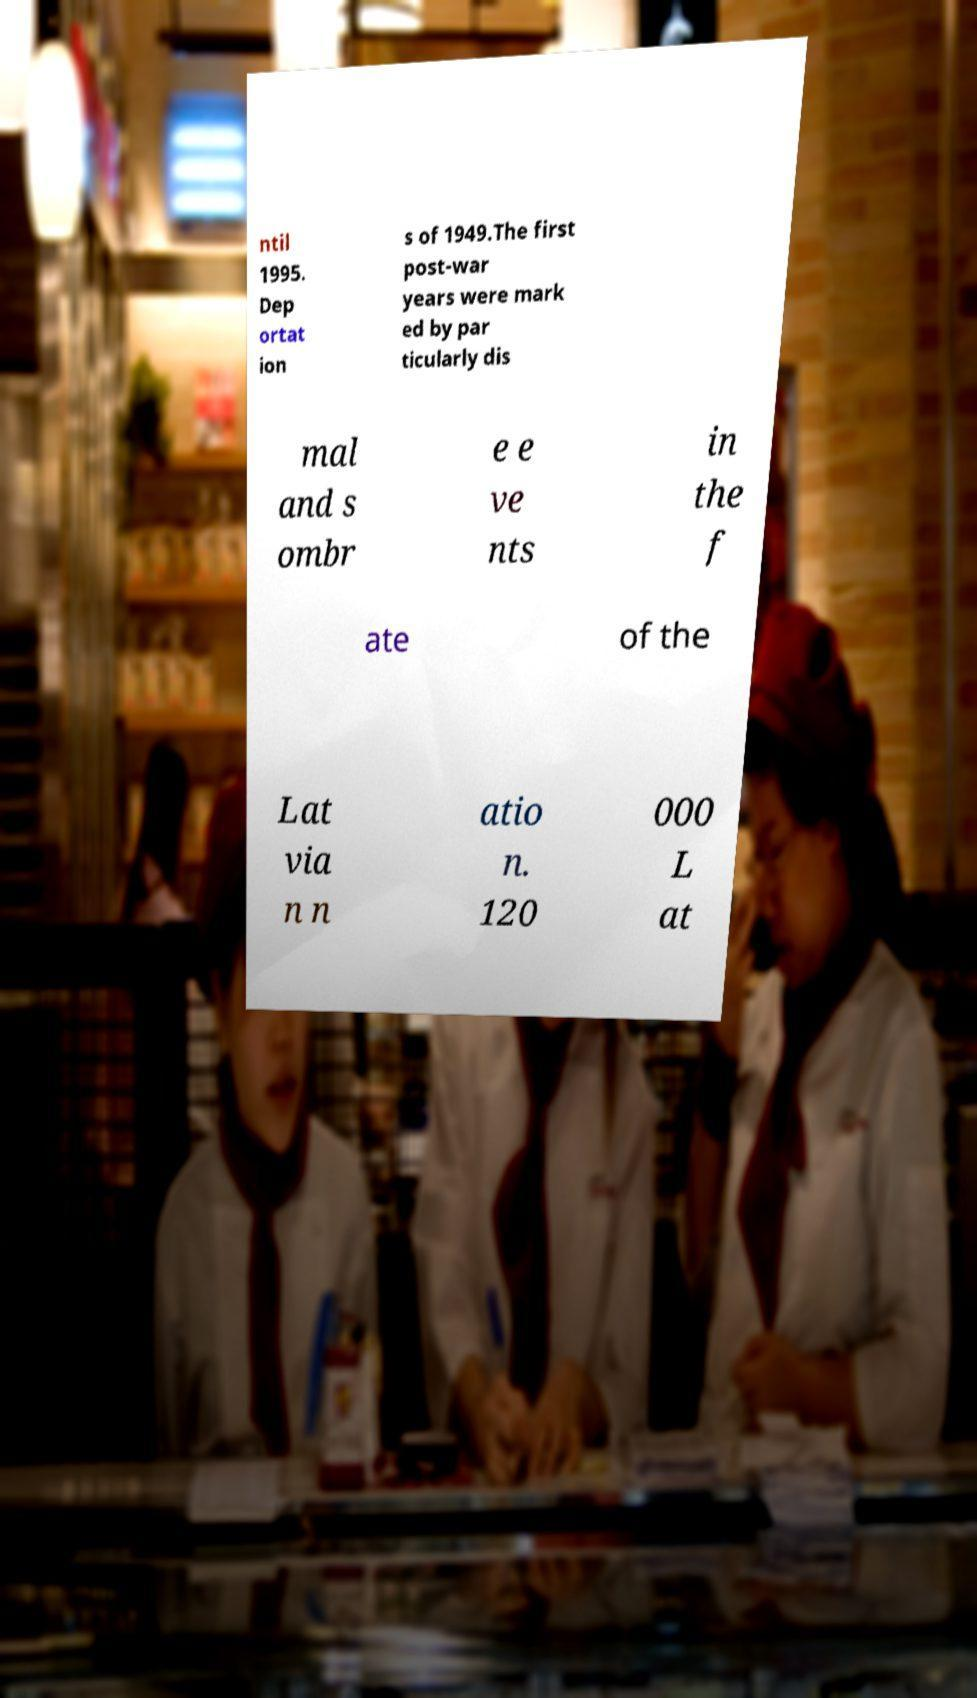I need the written content from this picture converted into text. Can you do that? ntil 1995. Dep ortat ion s of 1949.The first post-war years were mark ed by par ticularly dis mal and s ombr e e ve nts in the f ate of the Lat via n n atio n. 120 000 L at 